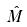<formula> <loc_0><loc_0><loc_500><loc_500>\hat { M }</formula> 